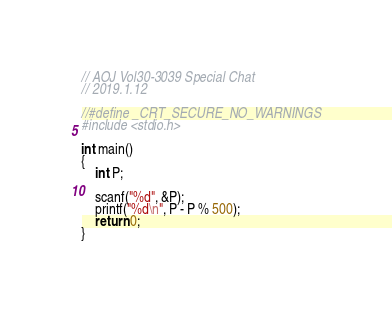Convert code to text. <code><loc_0><loc_0><loc_500><loc_500><_C_>// AOJ Vol30-3039 Special Chat
// 2019.1.12

//#define _CRT_SECURE_NO_WARNINGS
#include <stdio.h>

int main()
{
	int P;

	scanf("%d", &P);
	printf("%d\n", P - P % 500);
	return 0;
}
</code> 